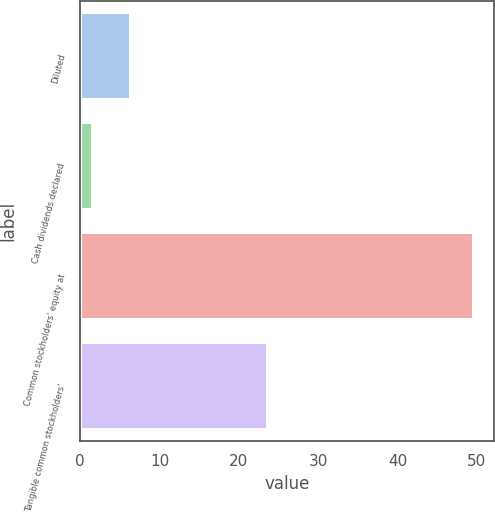<chart> <loc_0><loc_0><loc_500><loc_500><bar_chart><fcel>Diluted<fcel>Cash dividends declared<fcel>Common stockholders' equity at<fcel>Tangible common stockholders'<nl><fcel>6.41<fcel>1.6<fcel>49.68<fcel>23.62<nl></chart> 